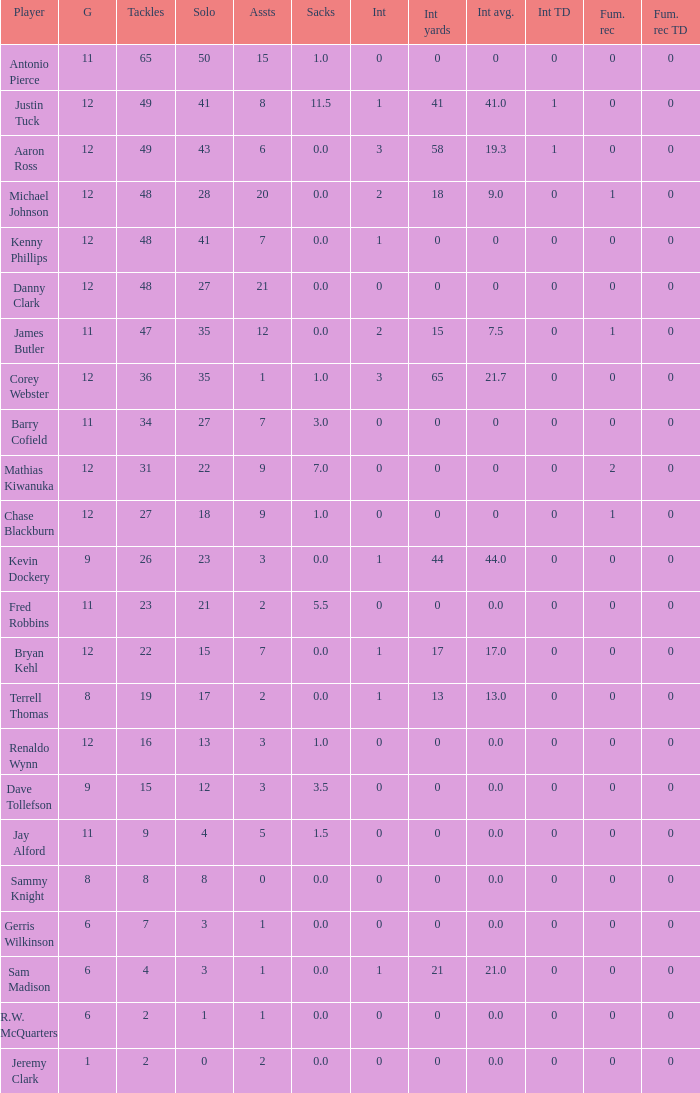What is the smallest fum rec td? 0.0. 